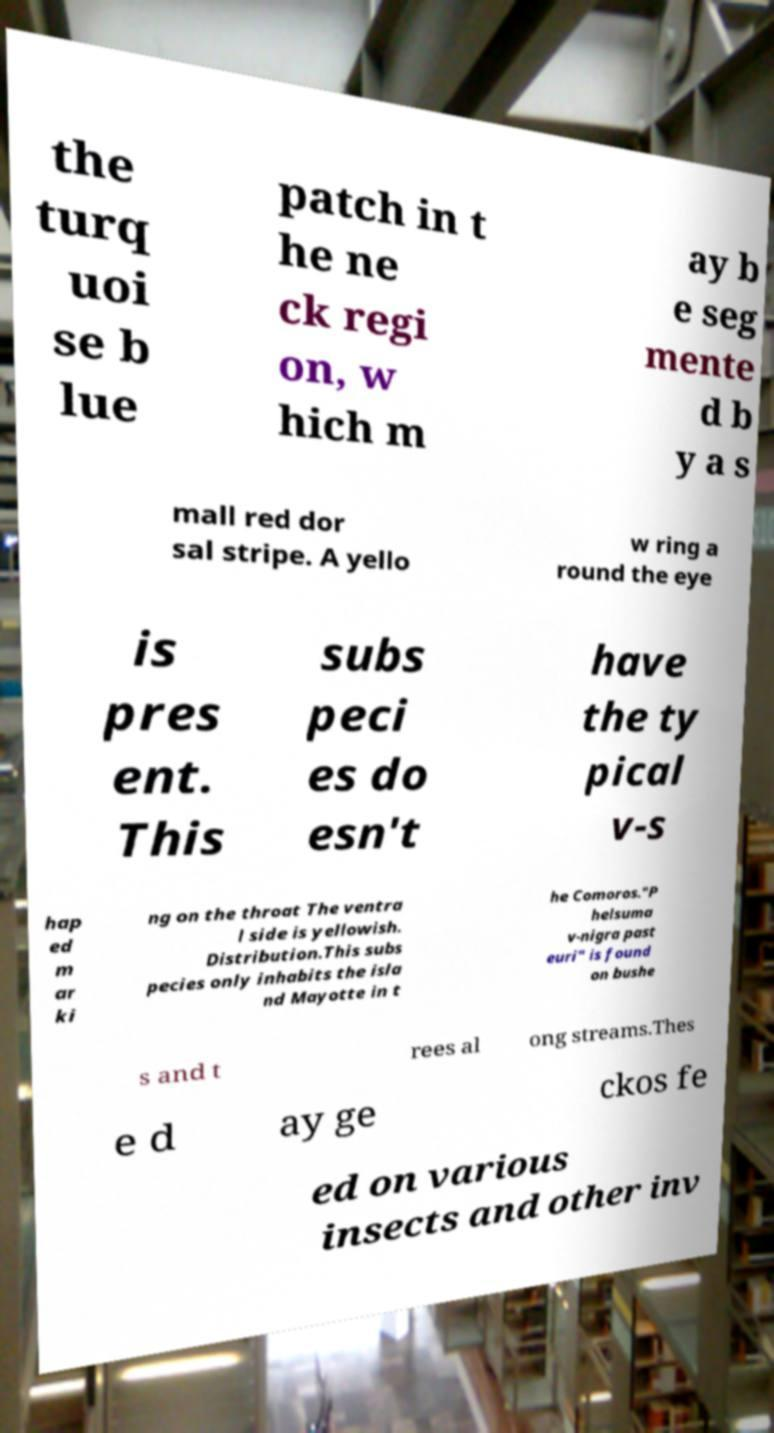Can you read and provide the text displayed in the image?This photo seems to have some interesting text. Can you extract and type it out for me? the turq uoi se b lue patch in t he ne ck regi on, w hich m ay b e seg mente d b y a s mall red dor sal stripe. A yello w ring a round the eye is pres ent. This subs peci es do esn't have the ty pical v-s hap ed m ar ki ng on the throat The ventra l side is yellowish. Distribution.This subs pecies only inhabits the isla nd Mayotte in t he Comoros."P helsuma v-nigra past euri" is found on bushe s and t rees al ong streams.Thes e d ay ge ckos fe ed on various insects and other inv 